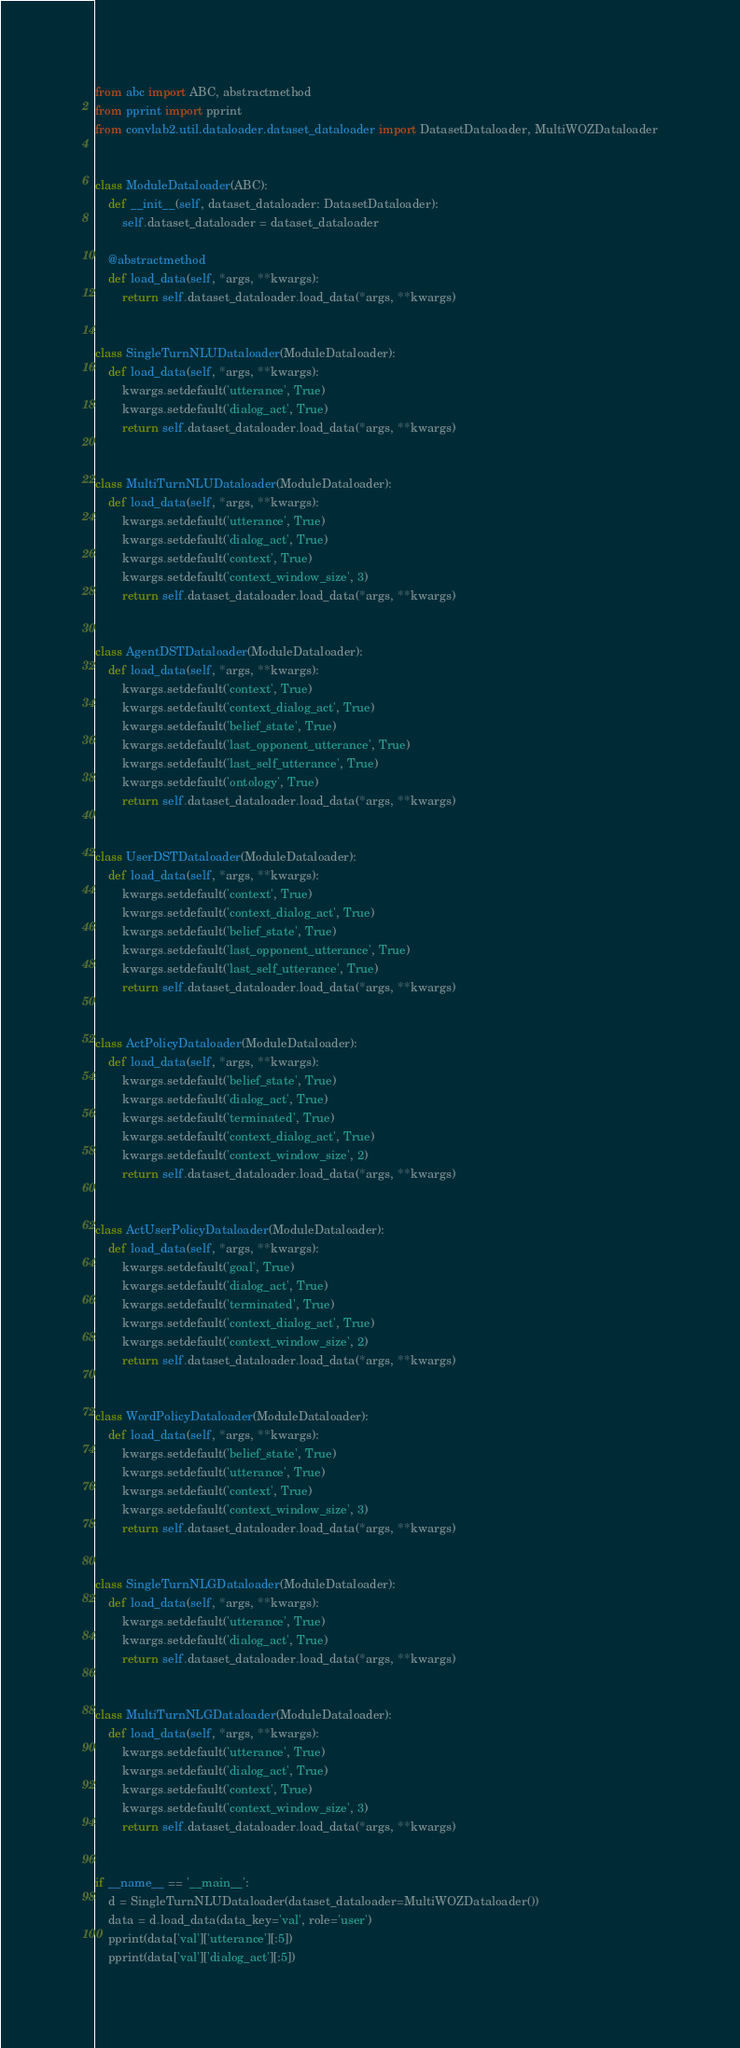Convert code to text. <code><loc_0><loc_0><loc_500><loc_500><_Python_>from abc import ABC, abstractmethod
from pprint import pprint
from convlab2.util.dataloader.dataset_dataloader import DatasetDataloader, MultiWOZDataloader


class ModuleDataloader(ABC):
    def __init__(self, dataset_dataloader: DatasetDataloader):
        self.dataset_dataloader = dataset_dataloader

    @abstractmethod
    def load_data(self, *args, **kwargs):
        return self.dataset_dataloader.load_data(*args, **kwargs)


class SingleTurnNLUDataloader(ModuleDataloader):
    def load_data(self, *args, **kwargs):
        kwargs.setdefault('utterance', True)
        kwargs.setdefault('dialog_act', True)
        return self.dataset_dataloader.load_data(*args, **kwargs)


class MultiTurnNLUDataloader(ModuleDataloader):
    def load_data(self, *args, **kwargs):
        kwargs.setdefault('utterance', True)
        kwargs.setdefault('dialog_act', True)
        kwargs.setdefault('context', True)
        kwargs.setdefault('context_window_size', 3)
        return self.dataset_dataloader.load_data(*args, **kwargs)


class AgentDSTDataloader(ModuleDataloader):
    def load_data(self, *args, **kwargs):
        kwargs.setdefault('context', True)
        kwargs.setdefault('context_dialog_act', True)
        kwargs.setdefault('belief_state', True)
        kwargs.setdefault('last_opponent_utterance', True)
        kwargs.setdefault('last_self_utterance', True)
        kwargs.setdefault('ontology', True)
        return self.dataset_dataloader.load_data(*args, **kwargs)


class UserDSTDataloader(ModuleDataloader):
    def load_data(self, *args, **kwargs):
        kwargs.setdefault('context', True)
        kwargs.setdefault('context_dialog_act', True)
        kwargs.setdefault('belief_state', True)
        kwargs.setdefault('last_opponent_utterance', True)
        kwargs.setdefault('last_self_utterance', True)
        return self.dataset_dataloader.load_data(*args, **kwargs)


class ActPolicyDataloader(ModuleDataloader):
    def load_data(self, *args, **kwargs):
        kwargs.setdefault('belief_state', True)
        kwargs.setdefault('dialog_act', True)
        kwargs.setdefault('terminated', True)
        kwargs.setdefault('context_dialog_act', True)
        kwargs.setdefault('context_window_size', 2)
        return self.dataset_dataloader.load_data(*args, **kwargs)


class ActUserPolicyDataloader(ModuleDataloader):
    def load_data(self, *args, **kwargs):
        kwargs.setdefault('goal', True)
        kwargs.setdefault('dialog_act', True)
        kwargs.setdefault('terminated', True)
        kwargs.setdefault('context_dialog_act', True)
        kwargs.setdefault('context_window_size', 2)
        return self.dataset_dataloader.load_data(*args, **kwargs)


class WordPolicyDataloader(ModuleDataloader):
    def load_data(self, *args, **kwargs):
        kwargs.setdefault('belief_state', True)
        kwargs.setdefault('utterance', True)
        kwargs.setdefault('context', True)
        kwargs.setdefault('context_window_size', 3)
        return self.dataset_dataloader.load_data(*args, **kwargs)


class SingleTurnNLGDataloader(ModuleDataloader):
    def load_data(self, *args, **kwargs):
        kwargs.setdefault('utterance', True)
        kwargs.setdefault('dialog_act', True)
        return self.dataset_dataloader.load_data(*args, **kwargs)


class MultiTurnNLGDataloader(ModuleDataloader):
    def load_data(self, *args, **kwargs):
        kwargs.setdefault('utterance', True)
        kwargs.setdefault('dialog_act', True)
        kwargs.setdefault('context', True)
        kwargs.setdefault('context_window_size', 3)
        return self.dataset_dataloader.load_data(*args, **kwargs)


if __name__ == '__main__':
    d = SingleTurnNLUDataloader(dataset_dataloader=MultiWOZDataloader())
    data = d.load_data(data_key='val', role='user')
    pprint(data['val']['utterance'][:5])
    pprint(data['val']['dialog_act'][:5])
</code> 